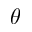<formula> <loc_0><loc_0><loc_500><loc_500>\theta</formula> 